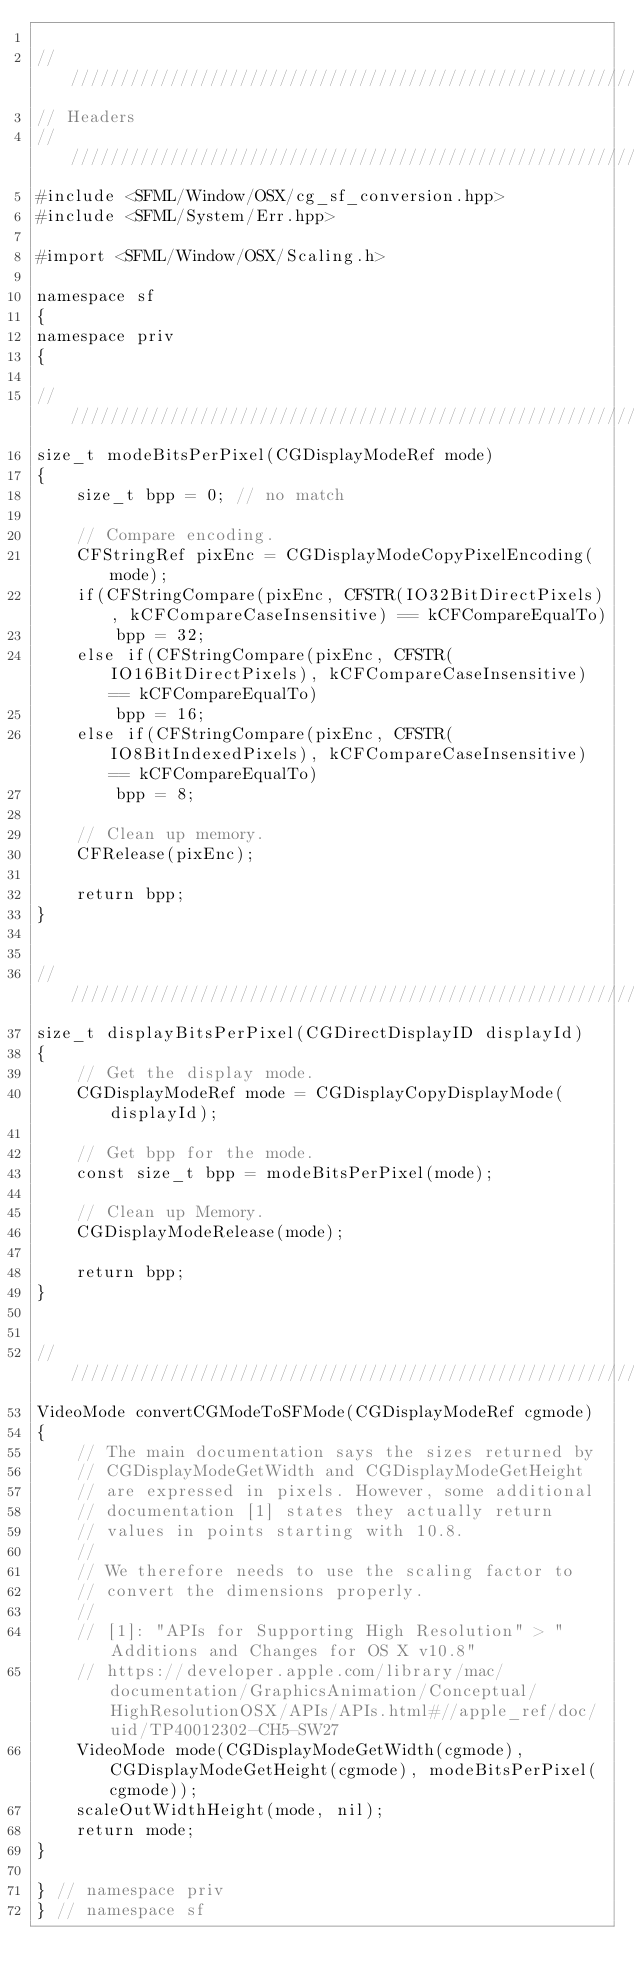<code> <loc_0><loc_0><loc_500><loc_500><_ObjectiveC_>
////////////////////////////////////////////////////////////
// Headers
////////////////////////////////////////////////////////////
#include <SFML/Window/OSX/cg_sf_conversion.hpp>
#include <SFML/System/Err.hpp>

#import <SFML/Window/OSX/Scaling.h>

namespace sf
{
namespace priv
{

////////////////////////////////////////////////////////////
size_t modeBitsPerPixel(CGDisplayModeRef mode)
{
    size_t bpp = 0; // no match

    // Compare encoding.
    CFStringRef pixEnc = CGDisplayModeCopyPixelEncoding(mode);
    if(CFStringCompare(pixEnc, CFSTR(IO32BitDirectPixels), kCFCompareCaseInsensitive) == kCFCompareEqualTo)
        bpp = 32;
    else if(CFStringCompare(pixEnc, CFSTR(IO16BitDirectPixels), kCFCompareCaseInsensitive) == kCFCompareEqualTo)
        bpp = 16;
    else if(CFStringCompare(pixEnc, CFSTR(IO8BitIndexedPixels), kCFCompareCaseInsensitive) == kCFCompareEqualTo)
        bpp = 8;

    // Clean up memory.
    CFRelease(pixEnc);

    return bpp;
}


////////////////////////////////////////////////////////////
size_t displayBitsPerPixel(CGDirectDisplayID displayId)
{
    // Get the display mode.
    CGDisplayModeRef mode = CGDisplayCopyDisplayMode(displayId);

    // Get bpp for the mode.
    const size_t bpp = modeBitsPerPixel(mode);

    // Clean up Memory.
    CGDisplayModeRelease(mode);

    return bpp;
}


////////////////////////////////////////////////////////////
VideoMode convertCGModeToSFMode(CGDisplayModeRef cgmode)
{
    // The main documentation says the sizes returned by
    // CGDisplayModeGetWidth and CGDisplayModeGetHeight
    // are expressed in pixels. However, some additional
    // documentation [1] states they actually return
    // values in points starting with 10.8.
    //
    // We therefore needs to use the scaling factor to
    // convert the dimensions properly.
    //
    // [1]: "APIs for Supporting High Resolution" > "Additions and Changes for OS X v10.8"
    // https://developer.apple.com/library/mac/documentation/GraphicsAnimation/Conceptual/HighResolutionOSX/APIs/APIs.html#//apple_ref/doc/uid/TP40012302-CH5-SW27
    VideoMode mode(CGDisplayModeGetWidth(cgmode), CGDisplayModeGetHeight(cgmode), modeBitsPerPixel(cgmode));
    scaleOutWidthHeight(mode, nil);
    return mode;
}

} // namespace priv
} // namespace sf

</code> 